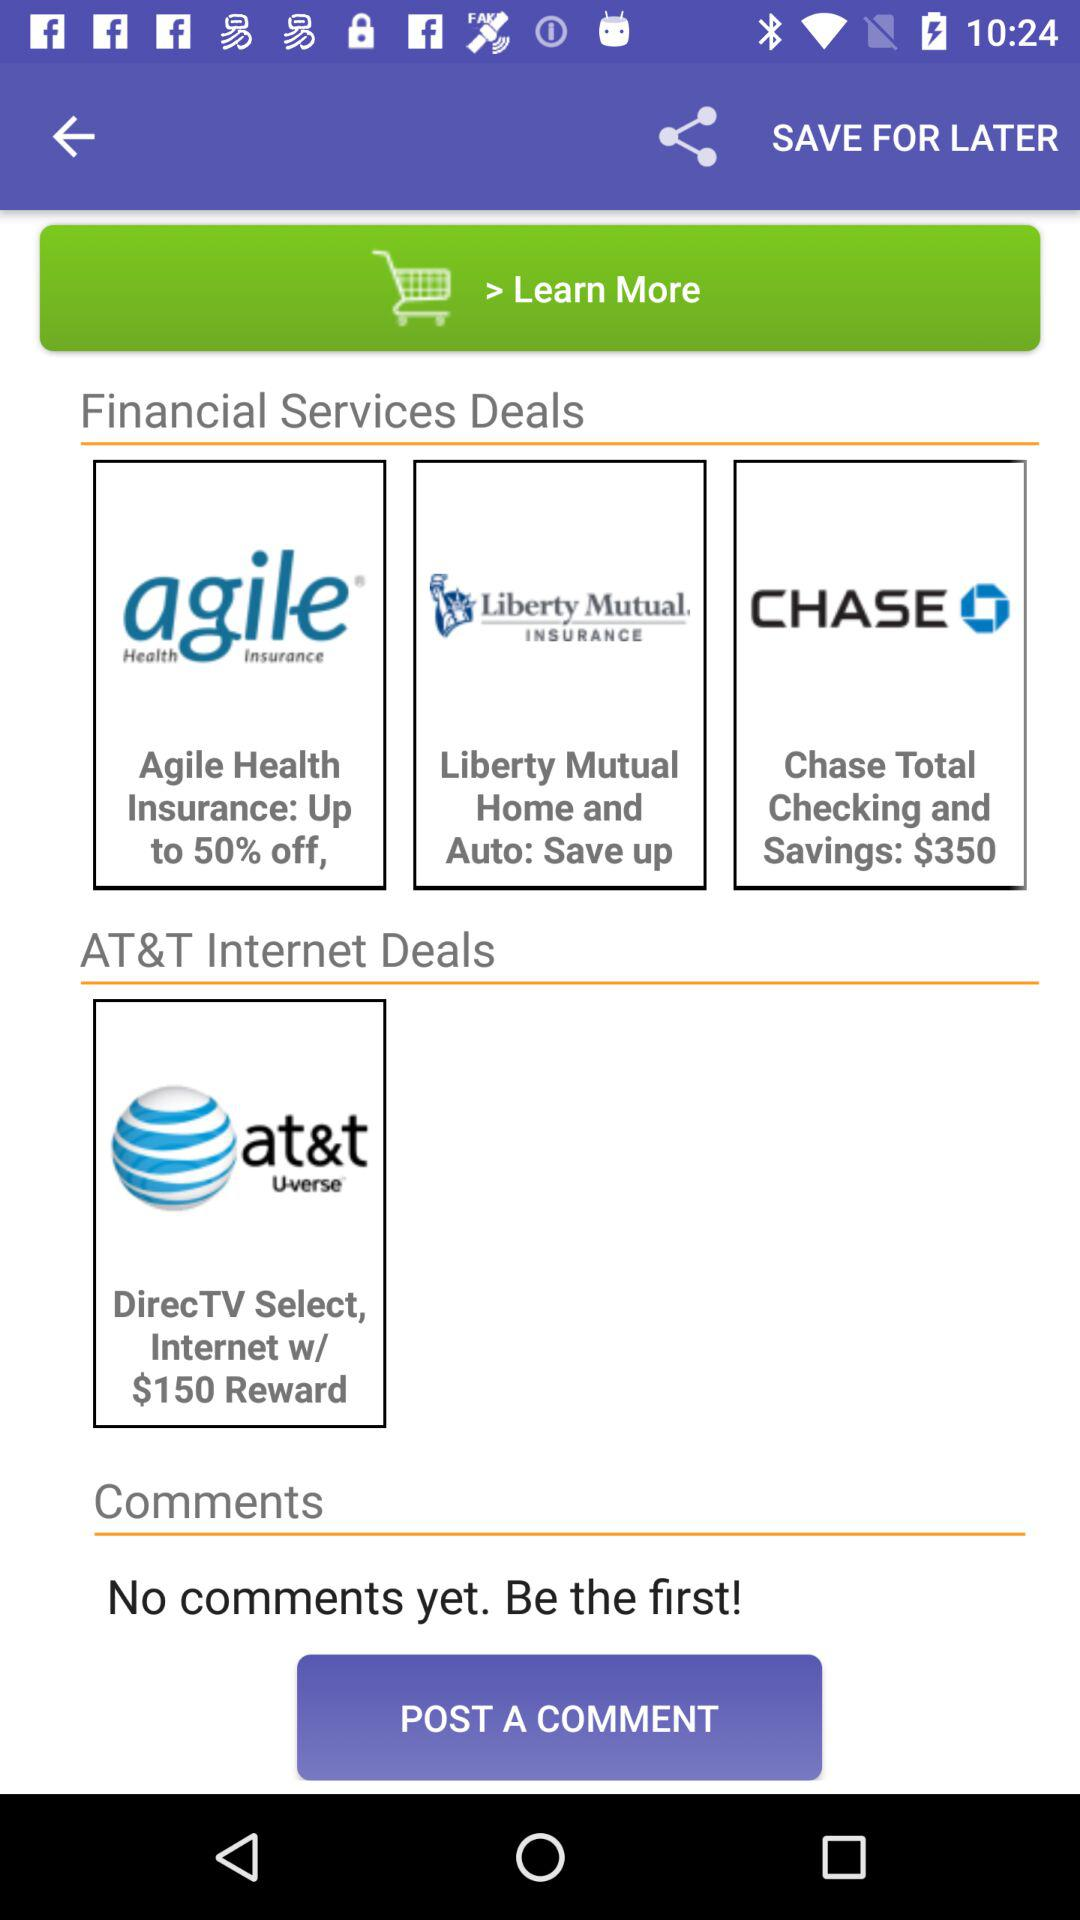How many more financial services deals are there than AT&T internet deals?
Answer the question using a single word or phrase. 2 